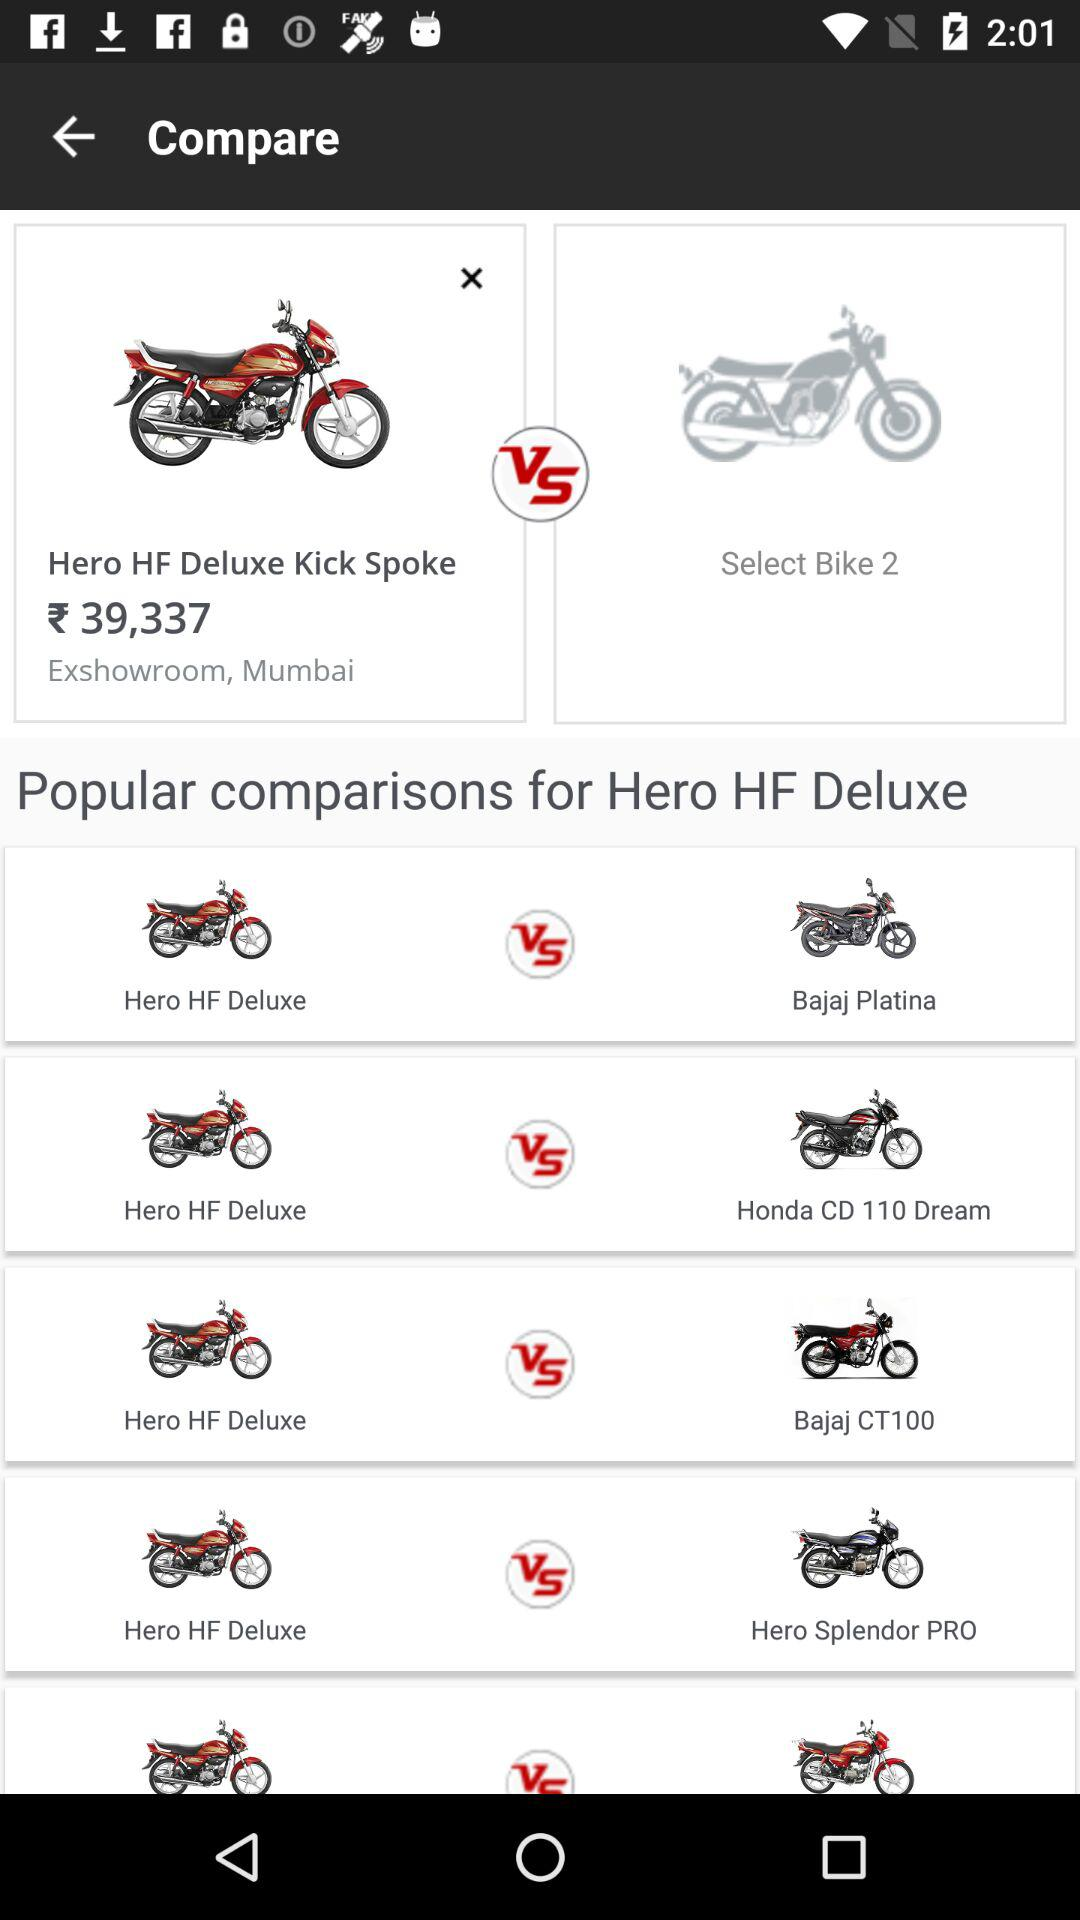For which bike are we checking the comparison? You are checking the comparison for the Hero HF Deluxe bike. 